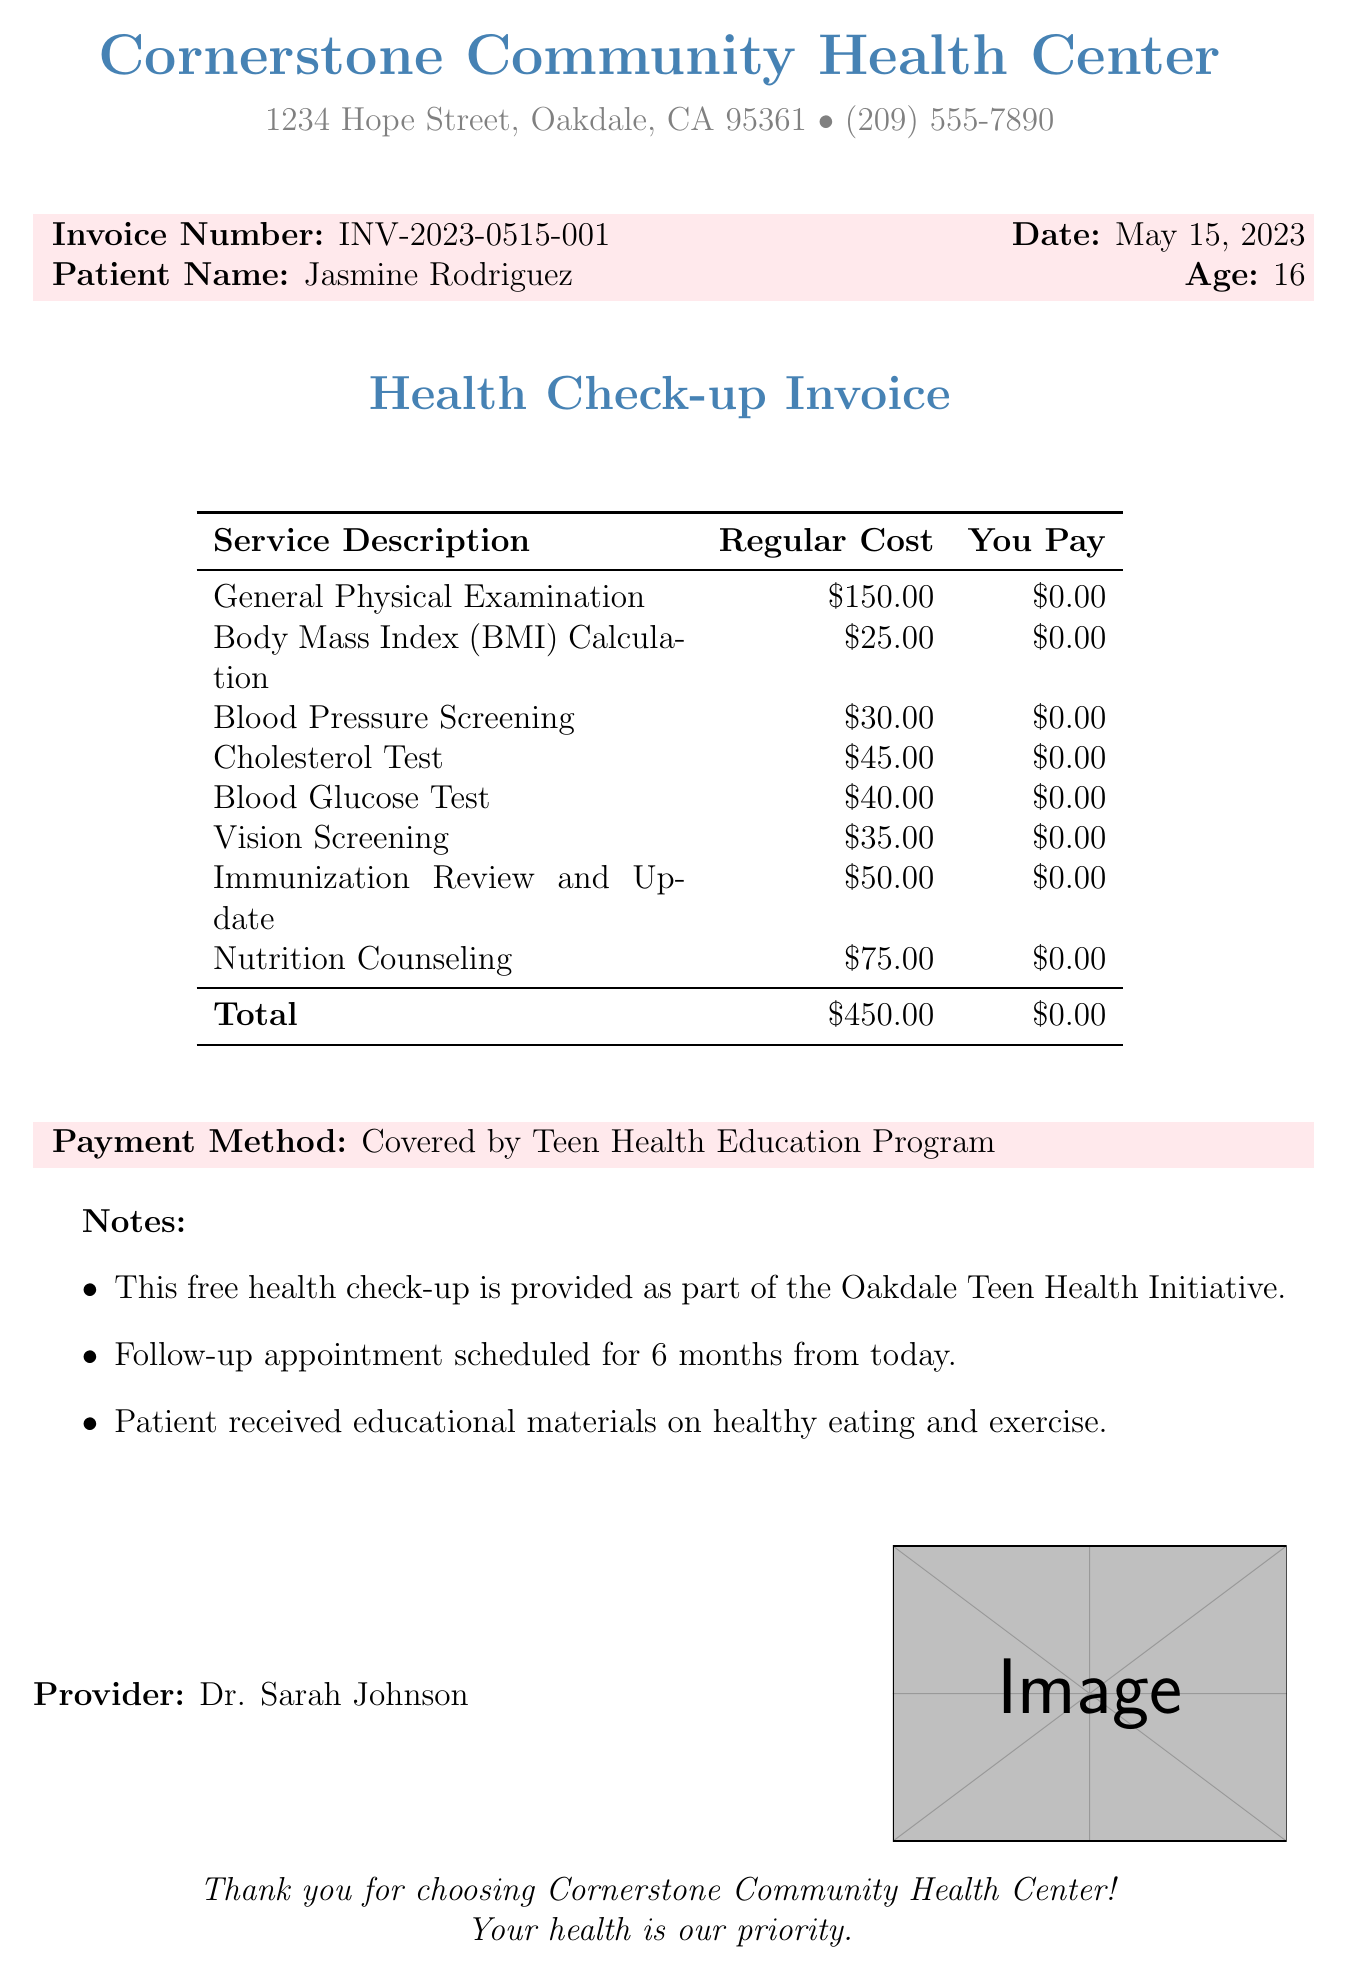What is the clinic name? The clinic name is stated clearly at the top of the document.
Answer: Cornerstone Community Health Center What is the patient's age? The patient's age is mentioned next to their name on the invoice.
Answer: 16 What date was the service provided? The date of service is prominently displayed in the invoice header.
Answer: May 15, 2023 What is the total regular cost of the services? The total regular cost is listed in the invoice table summarizing the service costs.
Answer: $450.00 Who is the provider of the services? The provider's name is mentioned at the bottom of the invoice.
Answer: Dr. Sarah Johnson What payment method was used? The payment method is indicated in a specific section of the document.
Answer: Covered by Teen Health Education Program How many services were provided in total? The list of services is detailed in the invoice table, each counted separately.
Answer: 8 What is one note mentioned in the invoice? The notes section provides additional information relevant to the health check-up.
Answer: Patient received educational materials on healthy eating and exercise 